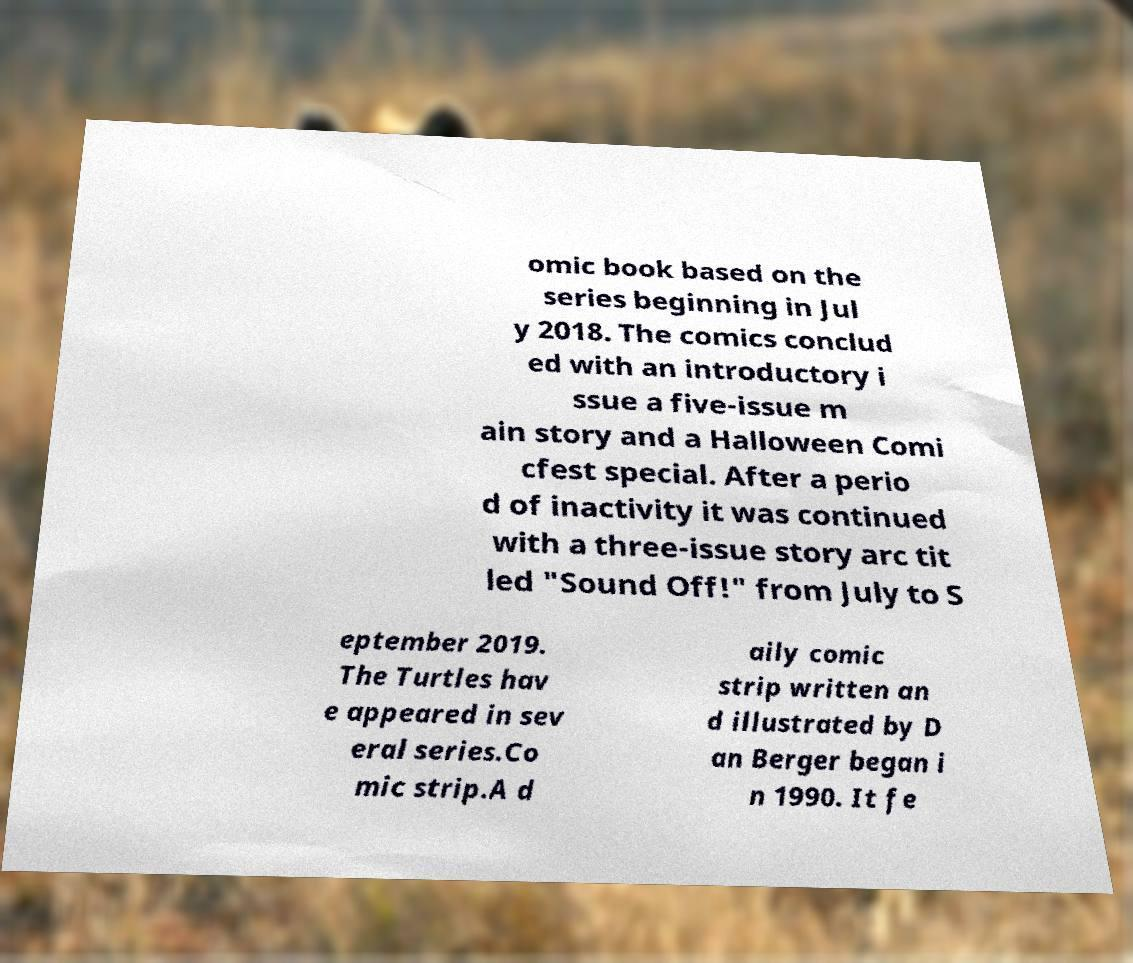Please identify and transcribe the text found in this image. omic book based on the series beginning in Jul y 2018. The comics conclud ed with an introductory i ssue a five-issue m ain story and a Halloween Comi cfest special. After a perio d of inactivity it was continued with a three-issue story arc tit led "Sound Off!" from July to S eptember 2019. The Turtles hav e appeared in sev eral series.Co mic strip.A d aily comic strip written an d illustrated by D an Berger began i n 1990. It fe 